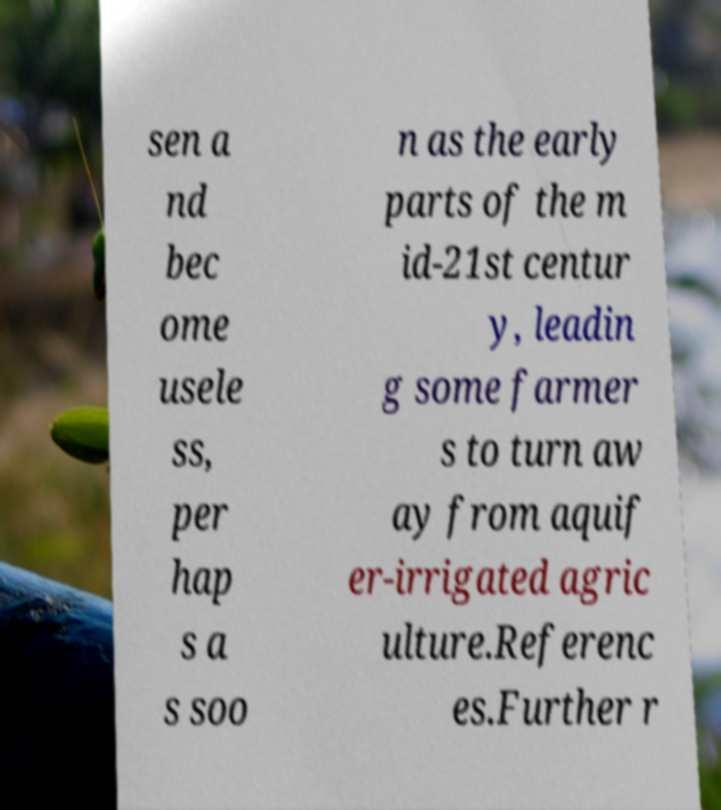Please read and relay the text visible in this image. What does it say? sen a nd bec ome usele ss, per hap s a s soo n as the early parts of the m id-21st centur y, leadin g some farmer s to turn aw ay from aquif er-irrigated agric ulture.Referenc es.Further r 